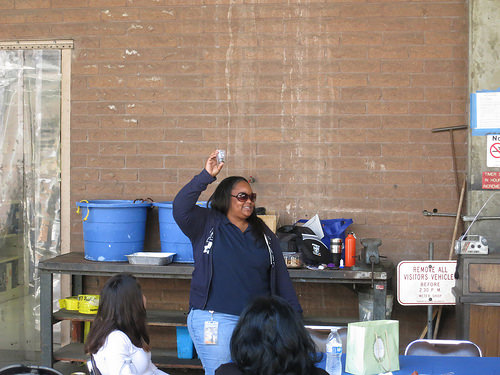<image>
Is there a woman in front of the bucket? Yes. The woman is positioned in front of the bucket, appearing closer to the camera viewpoint. 